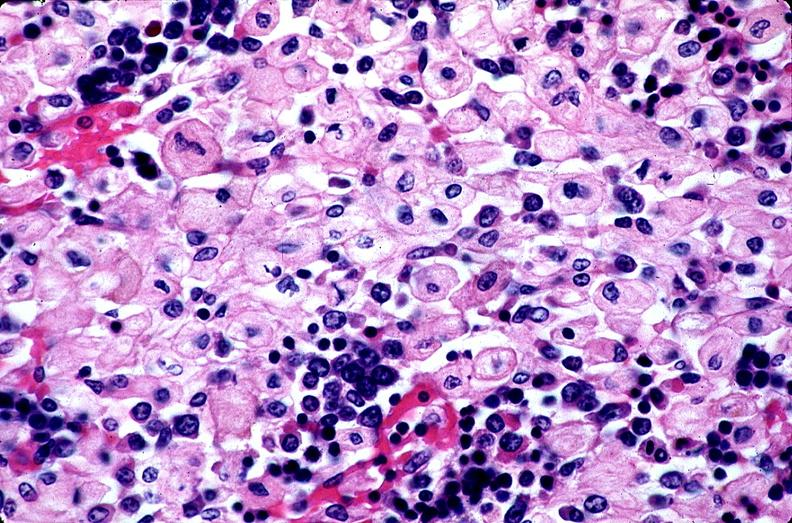does this image show gaucher disease?
Answer the question using a single word or phrase. Yes 